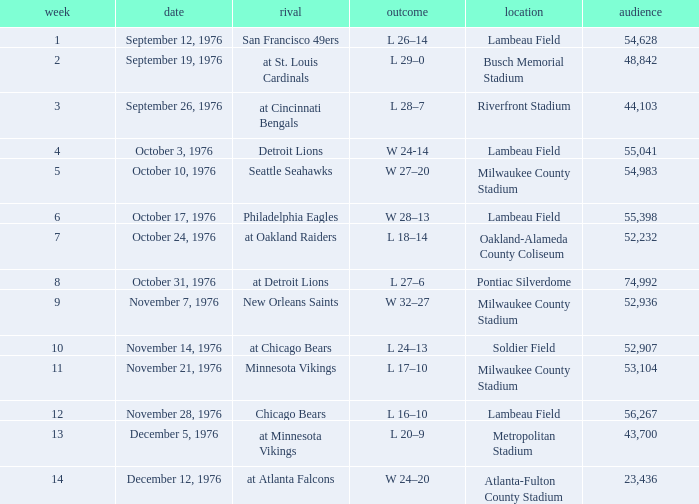What is the average attendance for the game on September 26, 1976? 44103.0. 